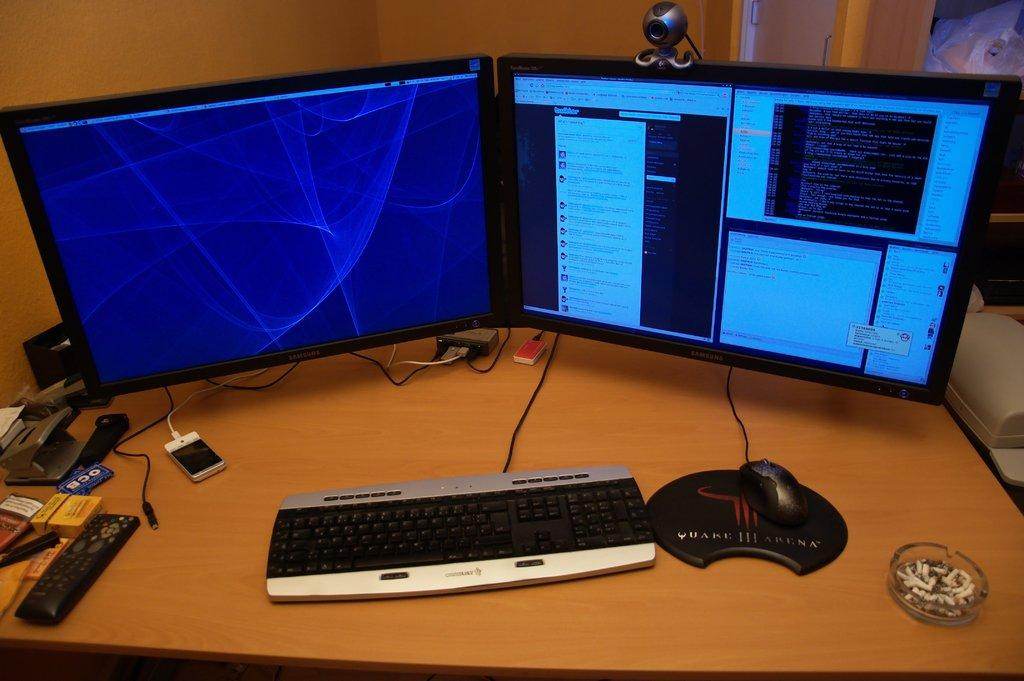What type of furniture is in the image? There is a table in the image. What electronic devices are on the table? There are two monitors, a keyboard, and a mouse visible on the table. Is there any communication device on the table? Yes, there is a mobile phone on the table. How many spiders are crawling on the keyboard in the image? There are no spiders present in the image; the keyboard is not shown to have any spiders crawling on it. 